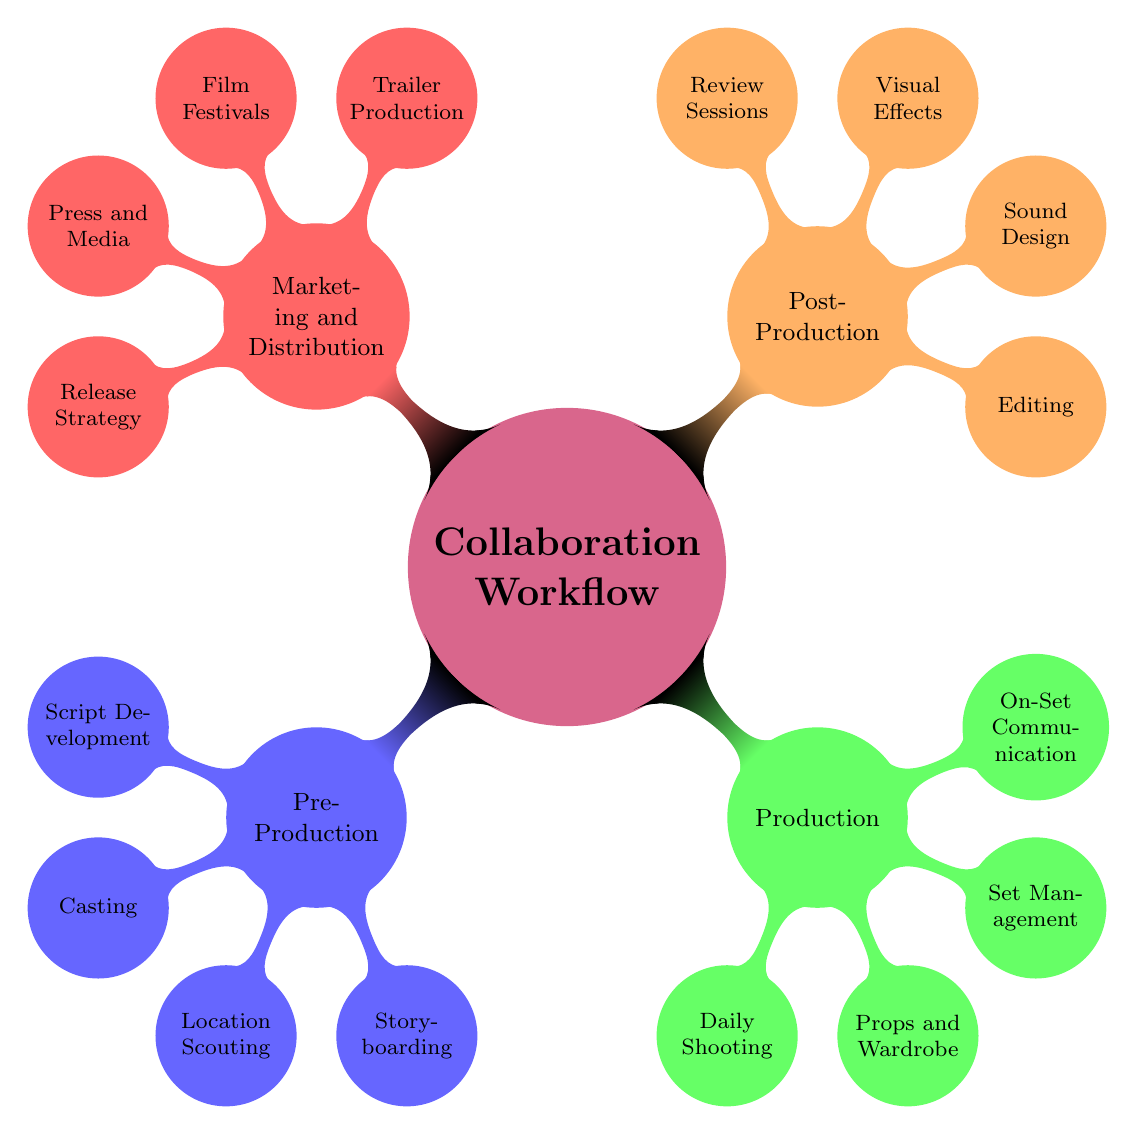What are the four main stages of the collaboration workflow? The diagram lists four main stages branching out from the central node: Pre-Production, Production, Post-Production, and Marketing and Distribution.
Answer: Pre-Production, Production, Post-Production, Marketing and Distribution How many processes are listed under Production? In the Production section, there are four processes: Daily Shooting, Props and Wardrobe, Set Management, and On-Set Communication.
Answer: Four Which phase includes "Editing" as a process? "Editing" is a specific process found in the Post-Production phase of the diagram.
Answer: Post-Production What task is part of the Marketing and Distribution phase? The diagram shows four tasks in the Marketing and Distribution phase, one of which is Trailer Production.
Answer: Trailer Production How many tasks are involved in Script Development? Under the Script Development node in the Pre-Production phase, there are two tasks: Adapt Novel and Screenwriting Sessions.
Answer: Two Which process involves "Daily Briefings"? Daily Briefings is a task under the On-Set Communication category, which is within the Production phase.
Answer: On-Set Communication What is the relationship between Storyboarding and Pre-Production? Storyboarding is a child node of Pre-Production, indicating that it is a essential part of the Pre-Production stage.
Answer: Pre-Production Which process is related to "CGI Implementation"? CGI Implementation is listed as part of the Visual Effects section, which in turn belongs to the Post-Production phase.
Answer: Visual Effects What are the two tasks listed under Sound Design? The diagram shows that Sound Design includes two tasks: Foley Effects and Soundtrack Integration.
Answer: Foley Effects, Soundtrack Integration 